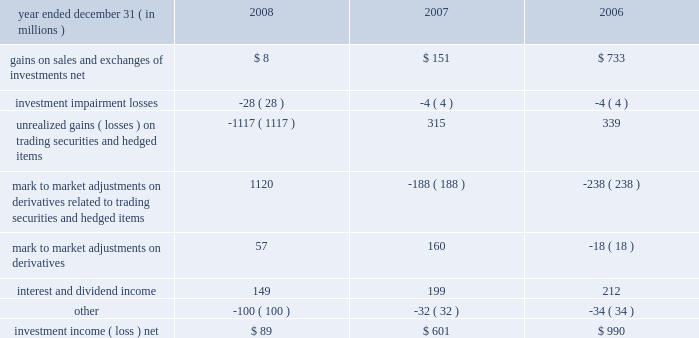Llc 201d ) , that will focus on the deployment of a nationwide 4g wire- less network .
We , together with the other members of the investor group , have invested $ 3.2 billion in clearwire llc .
Our portion of the investment was $ 1.05 billion .
As a result of our investment , we received ownership units ( 201cownership units 201d ) of clearwire llc and class b stock ( 201cvoting stock 201d ) of clearwire corporation , the pub- licly traded holding company that controls clearwire llc .
The voting stock has voting rights equal to those of the publicly traded class a stock of clearwire corporation , but has only minimal economic rights .
We hold our economic rights through the owner- ship units , which have limited voting rights .
One ownership unit combined with one share of voting stock are exchangeable into one share of clearwire corporation 2019s publicly traded class a stock .
At closing , we received 52.5 million ownership units and 52.5 million shares of voting stock , which represents an approx- imate 7% ( 7 % ) ownership interest on a fully diluted basis .
During the first quarter of 2009 , the purchase price per share is expected to be adjusted based on the trading prices of clearwire corporation 2019s publicly traded class a stock .
After the post-closing adjustment , we anticipate that we will have an approximate 8% ( 8 % ) ownership interest on a fully diluted basis .
In connection with the clearwire transaction , we entered into an agreement with sprint that allows us to offer wireless services utilizing certain of sprint 2019s existing wireless networks and an agreement with clearwire llc that allows us to offer wireless serv- ices utilizing clearwire 2019s next generation wireless broadband network .
We allocated a portion of our $ 1.05 billion investment to the related agreements .
We will account for our investment under the equity method and record our share of net income or loss one quarter in arrears .
Clearwire llc is expected to incur losses in the early years of operation , which under the equity method of accounting , will be reflected in our future operating results and reduce the cost basis of our investment .
We evaluated our investment at december 31 , 2008 to determine if an other than temporary decline in fair value below our cost basis had occurred .
The primary input in estimating the fair value of our investment was the quoted market value of clearwire publicly traded class a shares at december 31 , 2008 , which declined significantly from the date of our initial agreement in may 2008 .
As a result of the severe decline in the quoted market value , we recognized an impairment in other income ( expense ) of $ 600 million to adjust our cost basis in our investment to its esti- mated fair value .
In the future , our evaluation of other than temporary declines in fair value of our investment will include a comparison of actual operating results and updated forecasts to the projected discounted cash flows that were used in making our initial investment decision , other impairment indicators , such as changes in competition or technology , as well as a comparison to the value that would be obtained by exchanging our investment into clearwire corporation 2019s publicly traded class a shares .
Cost method airtouch communications , inc .
We hold two series of preferred stock of airtouch communica- tions , inc .
( 201cairtouch 201d ) , a subsidiary of vodafone , which are redeemable in april 2020 .
As of december 31 , 2008 and 2007 , the airtouch preferred stock was recorded at $ 1.479 billion and $ 1.465 billion , respectively .
As of december 31 , 2008 , the estimated fair value of the airtouch preferred stock was $ 1.357 billion , which is below our carrying amount .
The recent decline in fair value is attributable to changes in interest rates .
We have determined this decline to be temporary .
The factors considered were the length of time and the extent to which the market value has been less than cost , the credit rating of airtouch , and our intent and ability to retain the investment for a period of time sufficient to allow for recovery .
Specifically , we expect to hold the two series of airtouch preferred stock until their redemption in 2020 .
The dividend and redemption activity of the airtouch preferred stock determines the dividend and redemption payments asso- ciated with substantially all of the preferred shares issued by one of our consolidated subsidiaries , which is a vie .
The subsidiary has three series of preferred stock outstanding with an aggregate redemption value of $ 1.750 billion .
Substantially all of the preferred shares are redeemable in april 2020 at a redemption value of $ 1.650 billion .
As of december 31 , 2008 and 2007 , the two redeemable series of subsidiary preferred shares were recorded at $ 1.468 billion and $ 1.465 billion , respectively , and those amounts are included in other noncurrent liabilities .
The one nonredeemable series of subsidiary preferred shares was recorded at $ 100 million as of both december 31 , 2008 and 2007 and those amounts are included in minority interest on our consolidated balance sheet .
Investment income ( loss ) , net .
55 comcast 2008 annual report on form 10-k .
What was the percentage change in investment income ( loss ) net from 2007 to 2008? 
Computations: (89 - 601)
Answer: -512.0. Llc 201d ) , that will focus on the deployment of a nationwide 4g wire- less network .
We , together with the other members of the investor group , have invested $ 3.2 billion in clearwire llc .
Our portion of the investment was $ 1.05 billion .
As a result of our investment , we received ownership units ( 201cownership units 201d ) of clearwire llc and class b stock ( 201cvoting stock 201d ) of clearwire corporation , the pub- licly traded holding company that controls clearwire llc .
The voting stock has voting rights equal to those of the publicly traded class a stock of clearwire corporation , but has only minimal economic rights .
We hold our economic rights through the owner- ship units , which have limited voting rights .
One ownership unit combined with one share of voting stock are exchangeable into one share of clearwire corporation 2019s publicly traded class a stock .
At closing , we received 52.5 million ownership units and 52.5 million shares of voting stock , which represents an approx- imate 7% ( 7 % ) ownership interest on a fully diluted basis .
During the first quarter of 2009 , the purchase price per share is expected to be adjusted based on the trading prices of clearwire corporation 2019s publicly traded class a stock .
After the post-closing adjustment , we anticipate that we will have an approximate 8% ( 8 % ) ownership interest on a fully diluted basis .
In connection with the clearwire transaction , we entered into an agreement with sprint that allows us to offer wireless services utilizing certain of sprint 2019s existing wireless networks and an agreement with clearwire llc that allows us to offer wireless serv- ices utilizing clearwire 2019s next generation wireless broadband network .
We allocated a portion of our $ 1.05 billion investment to the related agreements .
We will account for our investment under the equity method and record our share of net income or loss one quarter in arrears .
Clearwire llc is expected to incur losses in the early years of operation , which under the equity method of accounting , will be reflected in our future operating results and reduce the cost basis of our investment .
We evaluated our investment at december 31 , 2008 to determine if an other than temporary decline in fair value below our cost basis had occurred .
The primary input in estimating the fair value of our investment was the quoted market value of clearwire publicly traded class a shares at december 31 , 2008 , which declined significantly from the date of our initial agreement in may 2008 .
As a result of the severe decline in the quoted market value , we recognized an impairment in other income ( expense ) of $ 600 million to adjust our cost basis in our investment to its esti- mated fair value .
In the future , our evaluation of other than temporary declines in fair value of our investment will include a comparison of actual operating results and updated forecasts to the projected discounted cash flows that were used in making our initial investment decision , other impairment indicators , such as changes in competition or technology , as well as a comparison to the value that would be obtained by exchanging our investment into clearwire corporation 2019s publicly traded class a shares .
Cost method airtouch communications , inc .
We hold two series of preferred stock of airtouch communica- tions , inc .
( 201cairtouch 201d ) , a subsidiary of vodafone , which are redeemable in april 2020 .
As of december 31 , 2008 and 2007 , the airtouch preferred stock was recorded at $ 1.479 billion and $ 1.465 billion , respectively .
As of december 31 , 2008 , the estimated fair value of the airtouch preferred stock was $ 1.357 billion , which is below our carrying amount .
The recent decline in fair value is attributable to changes in interest rates .
We have determined this decline to be temporary .
The factors considered were the length of time and the extent to which the market value has been less than cost , the credit rating of airtouch , and our intent and ability to retain the investment for a period of time sufficient to allow for recovery .
Specifically , we expect to hold the two series of airtouch preferred stock until their redemption in 2020 .
The dividend and redemption activity of the airtouch preferred stock determines the dividend and redemption payments asso- ciated with substantially all of the preferred shares issued by one of our consolidated subsidiaries , which is a vie .
The subsidiary has three series of preferred stock outstanding with an aggregate redemption value of $ 1.750 billion .
Substantially all of the preferred shares are redeemable in april 2020 at a redemption value of $ 1.650 billion .
As of december 31 , 2008 and 2007 , the two redeemable series of subsidiary preferred shares were recorded at $ 1.468 billion and $ 1.465 billion , respectively , and those amounts are included in other noncurrent liabilities .
The one nonredeemable series of subsidiary preferred shares was recorded at $ 100 million as of both december 31 , 2008 and 2007 and those amounts are included in minority interest on our consolidated balance sheet .
Investment income ( loss ) , net .
55 comcast 2008 annual report on form 10-k .
What was the percentage change in investment income ( loss ) net from 2006 to 2007? 
Computations: (601 - 990)
Answer: -389.0. Llc 201d ) , that will focus on the deployment of a nationwide 4g wire- less network .
We , together with the other members of the investor group , have invested $ 3.2 billion in clearwire llc .
Our portion of the investment was $ 1.05 billion .
As a result of our investment , we received ownership units ( 201cownership units 201d ) of clearwire llc and class b stock ( 201cvoting stock 201d ) of clearwire corporation , the pub- licly traded holding company that controls clearwire llc .
The voting stock has voting rights equal to those of the publicly traded class a stock of clearwire corporation , but has only minimal economic rights .
We hold our economic rights through the owner- ship units , which have limited voting rights .
One ownership unit combined with one share of voting stock are exchangeable into one share of clearwire corporation 2019s publicly traded class a stock .
At closing , we received 52.5 million ownership units and 52.5 million shares of voting stock , which represents an approx- imate 7% ( 7 % ) ownership interest on a fully diluted basis .
During the first quarter of 2009 , the purchase price per share is expected to be adjusted based on the trading prices of clearwire corporation 2019s publicly traded class a stock .
After the post-closing adjustment , we anticipate that we will have an approximate 8% ( 8 % ) ownership interest on a fully diluted basis .
In connection with the clearwire transaction , we entered into an agreement with sprint that allows us to offer wireless services utilizing certain of sprint 2019s existing wireless networks and an agreement with clearwire llc that allows us to offer wireless serv- ices utilizing clearwire 2019s next generation wireless broadband network .
We allocated a portion of our $ 1.05 billion investment to the related agreements .
We will account for our investment under the equity method and record our share of net income or loss one quarter in arrears .
Clearwire llc is expected to incur losses in the early years of operation , which under the equity method of accounting , will be reflected in our future operating results and reduce the cost basis of our investment .
We evaluated our investment at december 31 , 2008 to determine if an other than temporary decline in fair value below our cost basis had occurred .
The primary input in estimating the fair value of our investment was the quoted market value of clearwire publicly traded class a shares at december 31 , 2008 , which declined significantly from the date of our initial agreement in may 2008 .
As a result of the severe decline in the quoted market value , we recognized an impairment in other income ( expense ) of $ 600 million to adjust our cost basis in our investment to its esti- mated fair value .
In the future , our evaluation of other than temporary declines in fair value of our investment will include a comparison of actual operating results and updated forecasts to the projected discounted cash flows that were used in making our initial investment decision , other impairment indicators , such as changes in competition or technology , as well as a comparison to the value that would be obtained by exchanging our investment into clearwire corporation 2019s publicly traded class a shares .
Cost method airtouch communications , inc .
We hold two series of preferred stock of airtouch communica- tions , inc .
( 201cairtouch 201d ) , a subsidiary of vodafone , which are redeemable in april 2020 .
As of december 31 , 2008 and 2007 , the airtouch preferred stock was recorded at $ 1.479 billion and $ 1.465 billion , respectively .
As of december 31 , 2008 , the estimated fair value of the airtouch preferred stock was $ 1.357 billion , which is below our carrying amount .
The recent decline in fair value is attributable to changes in interest rates .
We have determined this decline to be temporary .
The factors considered were the length of time and the extent to which the market value has been less than cost , the credit rating of airtouch , and our intent and ability to retain the investment for a period of time sufficient to allow for recovery .
Specifically , we expect to hold the two series of airtouch preferred stock until their redemption in 2020 .
The dividend and redemption activity of the airtouch preferred stock determines the dividend and redemption payments asso- ciated with substantially all of the preferred shares issued by one of our consolidated subsidiaries , which is a vie .
The subsidiary has three series of preferred stock outstanding with an aggregate redemption value of $ 1.750 billion .
Substantially all of the preferred shares are redeemable in april 2020 at a redemption value of $ 1.650 billion .
As of december 31 , 2008 and 2007 , the two redeemable series of subsidiary preferred shares were recorded at $ 1.468 billion and $ 1.465 billion , respectively , and those amounts are included in other noncurrent liabilities .
The one nonredeemable series of subsidiary preferred shares was recorded at $ 100 million as of both december 31 , 2008 and 2007 and those amounts are included in minority interest on our consolidated balance sheet .
Investment income ( loss ) , net .
55 comcast 2008 annual report on form 10-k .
What was the average net investment income from 2006 to 2008? 
Computations: (((990 + (89 + 601)) + 3) / 2)
Answer: 841.5. 